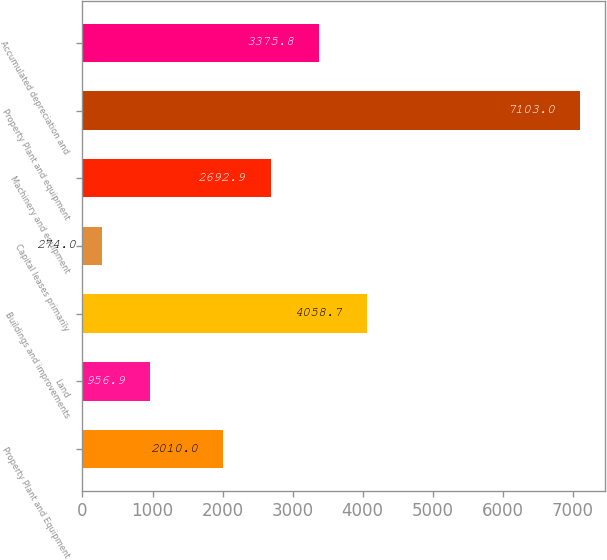<chart> <loc_0><loc_0><loc_500><loc_500><bar_chart><fcel>Property Plant and Equipment<fcel>Land<fcel>Buildings and improvements<fcel>Capital leases primarily<fcel>Machinery and equipment<fcel>Property Plant and equipment<fcel>Accumulated depreciation and<nl><fcel>2010<fcel>956.9<fcel>4058.7<fcel>274<fcel>2692.9<fcel>7103<fcel>3375.8<nl></chart> 